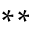Convert formula to latex. <formula><loc_0><loc_0><loc_500><loc_500>^ { * * }</formula> 